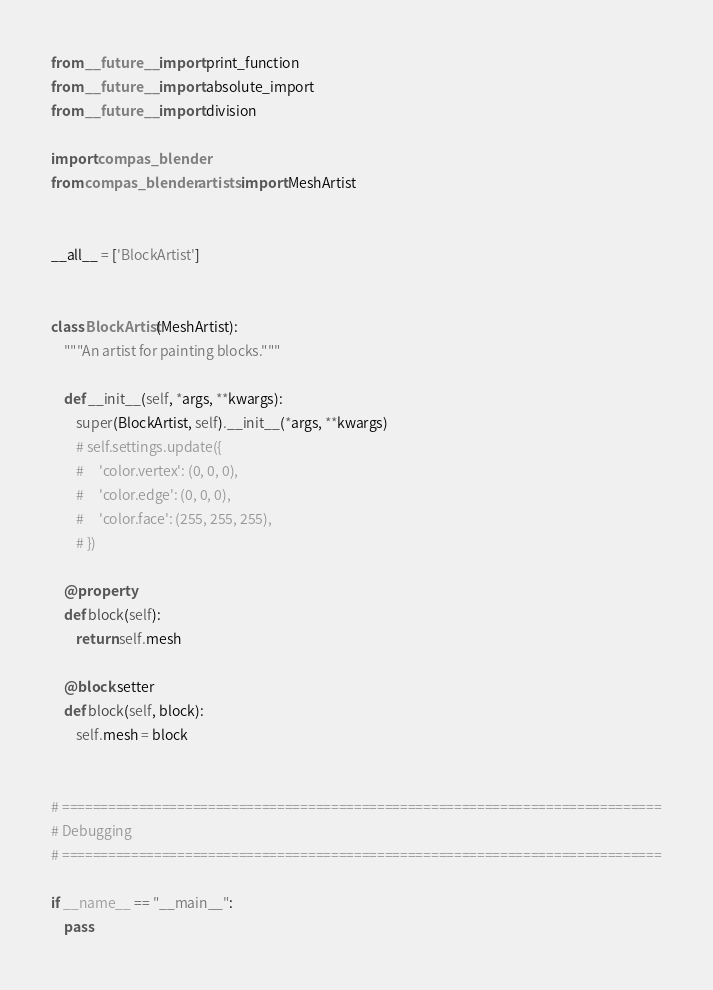<code> <loc_0><loc_0><loc_500><loc_500><_Python_>from __future__ import print_function
from __future__ import absolute_import
from __future__ import division

import compas_blender
from compas_blender.artists import MeshArtist


__all__ = ['BlockArtist']


class BlockArtist(MeshArtist):
    """An artist for painting blocks."""

    def __init__(self, *args, **kwargs):
        super(BlockArtist, self).__init__(*args, **kwargs)
        # self.settings.update({
        #     'color.vertex': (0, 0, 0),
        #     'color.edge': (0, 0, 0),
        #     'color.face': (255, 255, 255),
        # })

    @property
    def block(self):
        return self.mesh

    @block.setter
    def block(self, block):
        self.mesh = block


# ==============================================================================
# Debugging
# ==============================================================================

if __name__ == "__main__":
    pass
</code> 